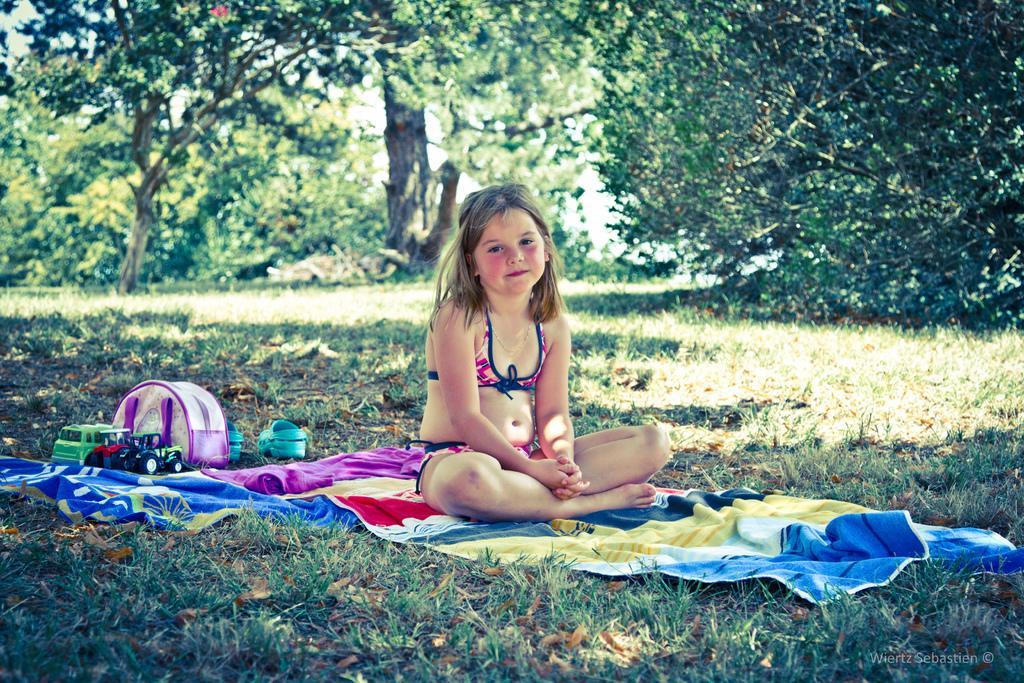Can you describe this image briefly? In the middle of this image, there is a girl, sitting on a cloth, which is on the grass on the ground. On the left side, there are toys, a box and shoes. In the background, there are trees and sky. 